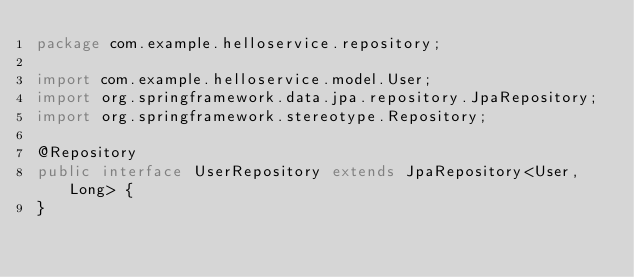Convert code to text. <code><loc_0><loc_0><loc_500><loc_500><_Java_>package com.example.helloservice.repository;

import com.example.helloservice.model.User;
import org.springframework.data.jpa.repository.JpaRepository;
import org.springframework.stereotype.Repository;

@Repository
public interface UserRepository extends JpaRepository<User, Long> {
}</code> 